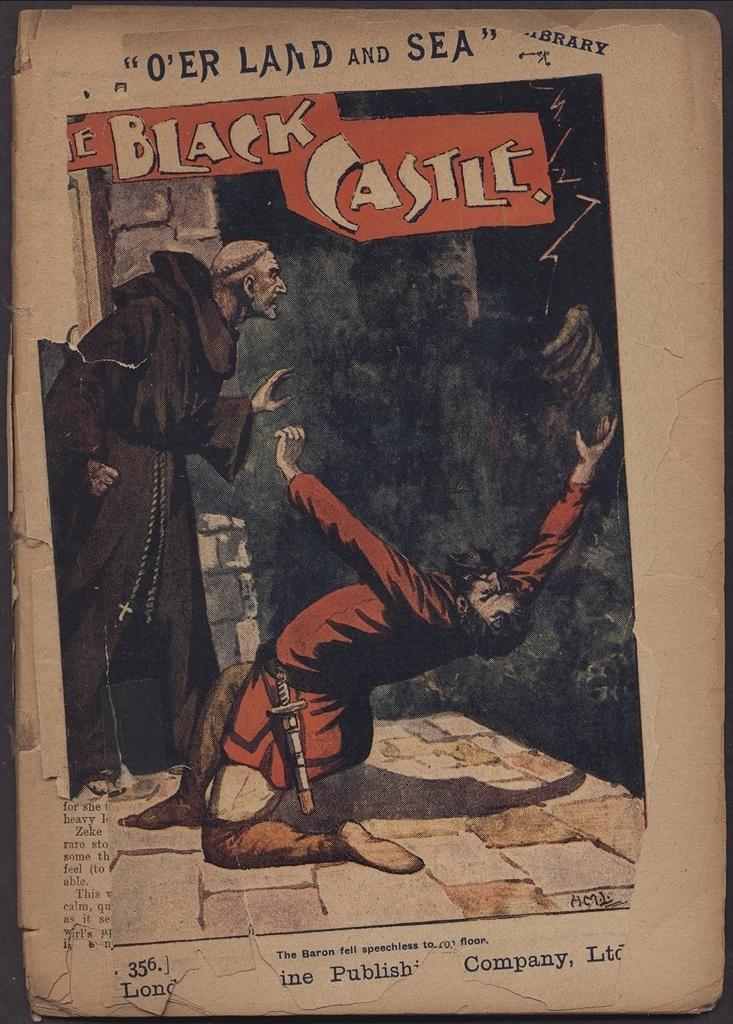Provide a one-sentence caption for the provided image. A weathered copy of a comic book titled The Black Castle. 